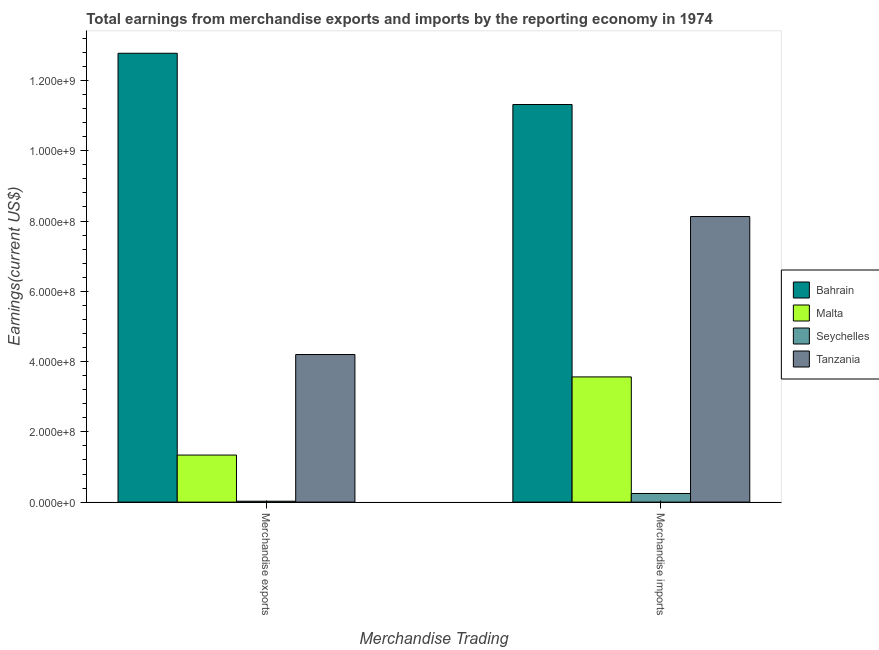How many different coloured bars are there?
Your answer should be compact. 4. Are the number of bars per tick equal to the number of legend labels?
Ensure brevity in your answer.  Yes. How many bars are there on the 2nd tick from the left?
Your answer should be very brief. 4. How many bars are there on the 1st tick from the right?
Keep it short and to the point. 4. What is the label of the 1st group of bars from the left?
Provide a succinct answer. Merchandise exports. What is the earnings from merchandise imports in Bahrain?
Your answer should be very brief. 1.13e+09. Across all countries, what is the maximum earnings from merchandise imports?
Provide a short and direct response. 1.13e+09. Across all countries, what is the minimum earnings from merchandise exports?
Offer a terse response. 2.60e+06. In which country was the earnings from merchandise exports maximum?
Your answer should be very brief. Bahrain. In which country was the earnings from merchandise exports minimum?
Offer a terse response. Seychelles. What is the total earnings from merchandise imports in the graph?
Make the answer very short. 2.33e+09. What is the difference between the earnings from merchandise exports in Tanzania and that in Seychelles?
Your answer should be very brief. 4.18e+08. What is the difference between the earnings from merchandise imports in Seychelles and the earnings from merchandise exports in Bahrain?
Give a very brief answer. -1.25e+09. What is the average earnings from merchandise imports per country?
Your answer should be very brief. 5.81e+08. What is the difference between the earnings from merchandise exports and earnings from merchandise imports in Bahrain?
Provide a short and direct response. 1.46e+08. What is the ratio of the earnings from merchandise exports in Malta to that in Tanzania?
Ensure brevity in your answer.  0.32. Is the earnings from merchandise imports in Malta less than that in Tanzania?
Make the answer very short. Yes. In how many countries, is the earnings from merchandise imports greater than the average earnings from merchandise imports taken over all countries?
Give a very brief answer. 2. What does the 3rd bar from the left in Merchandise imports represents?
Your answer should be very brief. Seychelles. What does the 1st bar from the right in Merchandise exports represents?
Provide a short and direct response. Tanzania. How many bars are there?
Offer a terse response. 8. How many countries are there in the graph?
Provide a succinct answer. 4. What is the difference between two consecutive major ticks on the Y-axis?
Make the answer very short. 2.00e+08. Does the graph contain any zero values?
Provide a short and direct response. No. Where does the legend appear in the graph?
Ensure brevity in your answer.  Center right. How are the legend labels stacked?
Offer a terse response. Vertical. What is the title of the graph?
Your answer should be compact. Total earnings from merchandise exports and imports by the reporting economy in 1974. What is the label or title of the X-axis?
Make the answer very short. Merchandise Trading. What is the label or title of the Y-axis?
Keep it short and to the point. Earnings(current US$). What is the Earnings(current US$) in Bahrain in Merchandise exports?
Your answer should be compact. 1.28e+09. What is the Earnings(current US$) in Malta in Merchandise exports?
Provide a short and direct response. 1.34e+08. What is the Earnings(current US$) in Seychelles in Merchandise exports?
Keep it short and to the point. 2.60e+06. What is the Earnings(current US$) of Tanzania in Merchandise exports?
Give a very brief answer. 4.20e+08. What is the Earnings(current US$) of Bahrain in Merchandise imports?
Offer a terse response. 1.13e+09. What is the Earnings(current US$) in Malta in Merchandise imports?
Offer a terse response. 3.56e+08. What is the Earnings(current US$) of Seychelles in Merchandise imports?
Give a very brief answer. 2.46e+07. What is the Earnings(current US$) of Tanzania in Merchandise imports?
Provide a succinct answer. 8.13e+08. Across all Merchandise Trading, what is the maximum Earnings(current US$) in Bahrain?
Make the answer very short. 1.28e+09. Across all Merchandise Trading, what is the maximum Earnings(current US$) in Malta?
Your answer should be very brief. 3.56e+08. Across all Merchandise Trading, what is the maximum Earnings(current US$) of Seychelles?
Provide a short and direct response. 2.46e+07. Across all Merchandise Trading, what is the maximum Earnings(current US$) in Tanzania?
Your answer should be compact. 8.13e+08. Across all Merchandise Trading, what is the minimum Earnings(current US$) in Bahrain?
Keep it short and to the point. 1.13e+09. Across all Merchandise Trading, what is the minimum Earnings(current US$) of Malta?
Offer a terse response. 1.34e+08. Across all Merchandise Trading, what is the minimum Earnings(current US$) of Seychelles?
Ensure brevity in your answer.  2.60e+06. Across all Merchandise Trading, what is the minimum Earnings(current US$) of Tanzania?
Give a very brief answer. 4.20e+08. What is the total Earnings(current US$) in Bahrain in the graph?
Your response must be concise. 2.41e+09. What is the total Earnings(current US$) in Malta in the graph?
Ensure brevity in your answer.  4.90e+08. What is the total Earnings(current US$) of Seychelles in the graph?
Offer a terse response. 2.72e+07. What is the total Earnings(current US$) of Tanzania in the graph?
Give a very brief answer. 1.23e+09. What is the difference between the Earnings(current US$) in Bahrain in Merchandise exports and that in Merchandise imports?
Ensure brevity in your answer.  1.46e+08. What is the difference between the Earnings(current US$) in Malta in Merchandise exports and that in Merchandise imports?
Keep it short and to the point. -2.22e+08. What is the difference between the Earnings(current US$) in Seychelles in Merchandise exports and that in Merchandise imports?
Keep it short and to the point. -2.20e+07. What is the difference between the Earnings(current US$) in Tanzania in Merchandise exports and that in Merchandise imports?
Ensure brevity in your answer.  -3.93e+08. What is the difference between the Earnings(current US$) of Bahrain in Merchandise exports and the Earnings(current US$) of Malta in Merchandise imports?
Keep it short and to the point. 9.21e+08. What is the difference between the Earnings(current US$) in Bahrain in Merchandise exports and the Earnings(current US$) in Seychelles in Merchandise imports?
Your response must be concise. 1.25e+09. What is the difference between the Earnings(current US$) of Bahrain in Merchandise exports and the Earnings(current US$) of Tanzania in Merchandise imports?
Make the answer very short. 4.65e+08. What is the difference between the Earnings(current US$) in Malta in Merchandise exports and the Earnings(current US$) in Seychelles in Merchandise imports?
Give a very brief answer. 1.09e+08. What is the difference between the Earnings(current US$) of Malta in Merchandise exports and the Earnings(current US$) of Tanzania in Merchandise imports?
Ensure brevity in your answer.  -6.79e+08. What is the difference between the Earnings(current US$) of Seychelles in Merchandise exports and the Earnings(current US$) of Tanzania in Merchandise imports?
Offer a terse response. -8.10e+08. What is the average Earnings(current US$) of Bahrain per Merchandise Trading?
Provide a succinct answer. 1.20e+09. What is the average Earnings(current US$) in Malta per Merchandise Trading?
Provide a short and direct response. 2.45e+08. What is the average Earnings(current US$) in Seychelles per Merchandise Trading?
Offer a very short reply. 1.36e+07. What is the average Earnings(current US$) in Tanzania per Merchandise Trading?
Provide a succinct answer. 6.16e+08. What is the difference between the Earnings(current US$) in Bahrain and Earnings(current US$) in Malta in Merchandise exports?
Offer a very short reply. 1.14e+09. What is the difference between the Earnings(current US$) of Bahrain and Earnings(current US$) of Seychelles in Merchandise exports?
Your response must be concise. 1.27e+09. What is the difference between the Earnings(current US$) in Bahrain and Earnings(current US$) in Tanzania in Merchandise exports?
Give a very brief answer. 8.57e+08. What is the difference between the Earnings(current US$) of Malta and Earnings(current US$) of Seychelles in Merchandise exports?
Offer a terse response. 1.31e+08. What is the difference between the Earnings(current US$) of Malta and Earnings(current US$) of Tanzania in Merchandise exports?
Your answer should be very brief. -2.86e+08. What is the difference between the Earnings(current US$) of Seychelles and Earnings(current US$) of Tanzania in Merchandise exports?
Give a very brief answer. -4.18e+08. What is the difference between the Earnings(current US$) of Bahrain and Earnings(current US$) of Malta in Merchandise imports?
Ensure brevity in your answer.  7.75e+08. What is the difference between the Earnings(current US$) in Bahrain and Earnings(current US$) in Seychelles in Merchandise imports?
Provide a short and direct response. 1.11e+09. What is the difference between the Earnings(current US$) in Bahrain and Earnings(current US$) in Tanzania in Merchandise imports?
Provide a short and direct response. 3.19e+08. What is the difference between the Earnings(current US$) of Malta and Earnings(current US$) of Seychelles in Merchandise imports?
Offer a terse response. 3.32e+08. What is the difference between the Earnings(current US$) of Malta and Earnings(current US$) of Tanzania in Merchandise imports?
Your answer should be very brief. -4.56e+08. What is the difference between the Earnings(current US$) in Seychelles and Earnings(current US$) in Tanzania in Merchandise imports?
Provide a short and direct response. -7.88e+08. What is the ratio of the Earnings(current US$) in Bahrain in Merchandise exports to that in Merchandise imports?
Your response must be concise. 1.13. What is the ratio of the Earnings(current US$) in Malta in Merchandise exports to that in Merchandise imports?
Your response must be concise. 0.38. What is the ratio of the Earnings(current US$) in Seychelles in Merchandise exports to that in Merchandise imports?
Provide a succinct answer. 0.11. What is the ratio of the Earnings(current US$) in Tanzania in Merchandise exports to that in Merchandise imports?
Your answer should be very brief. 0.52. What is the difference between the highest and the second highest Earnings(current US$) of Bahrain?
Provide a short and direct response. 1.46e+08. What is the difference between the highest and the second highest Earnings(current US$) of Malta?
Make the answer very short. 2.22e+08. What is the difference between the highest and the second highest Earnings(current US$) of Seychelles?
Provide a succinct answer. 2.20e+07. What is the difference between the highest and the second highest Earnings(current US$) in Tanzania?
Your answer should be very brief. 3.93e+08. What is the difference between the highest and the lowest Earnings(current US$) in Bahrain?
Make the answer very short. 1.46e+08. What is the difference between the highest and the lowest Earnings(current US$) of Malta?
Your answer should be compact. 2.22e+08. What is the difference between the highest and the lowest Earnings(current US$) in Seychelles?
Ensure brevity in your answer.  2.20e+07. What is the difference between the highest and the lowest Earnings(current US$) of Tanzania?
Offer a very short reply. 3.93e+08. 